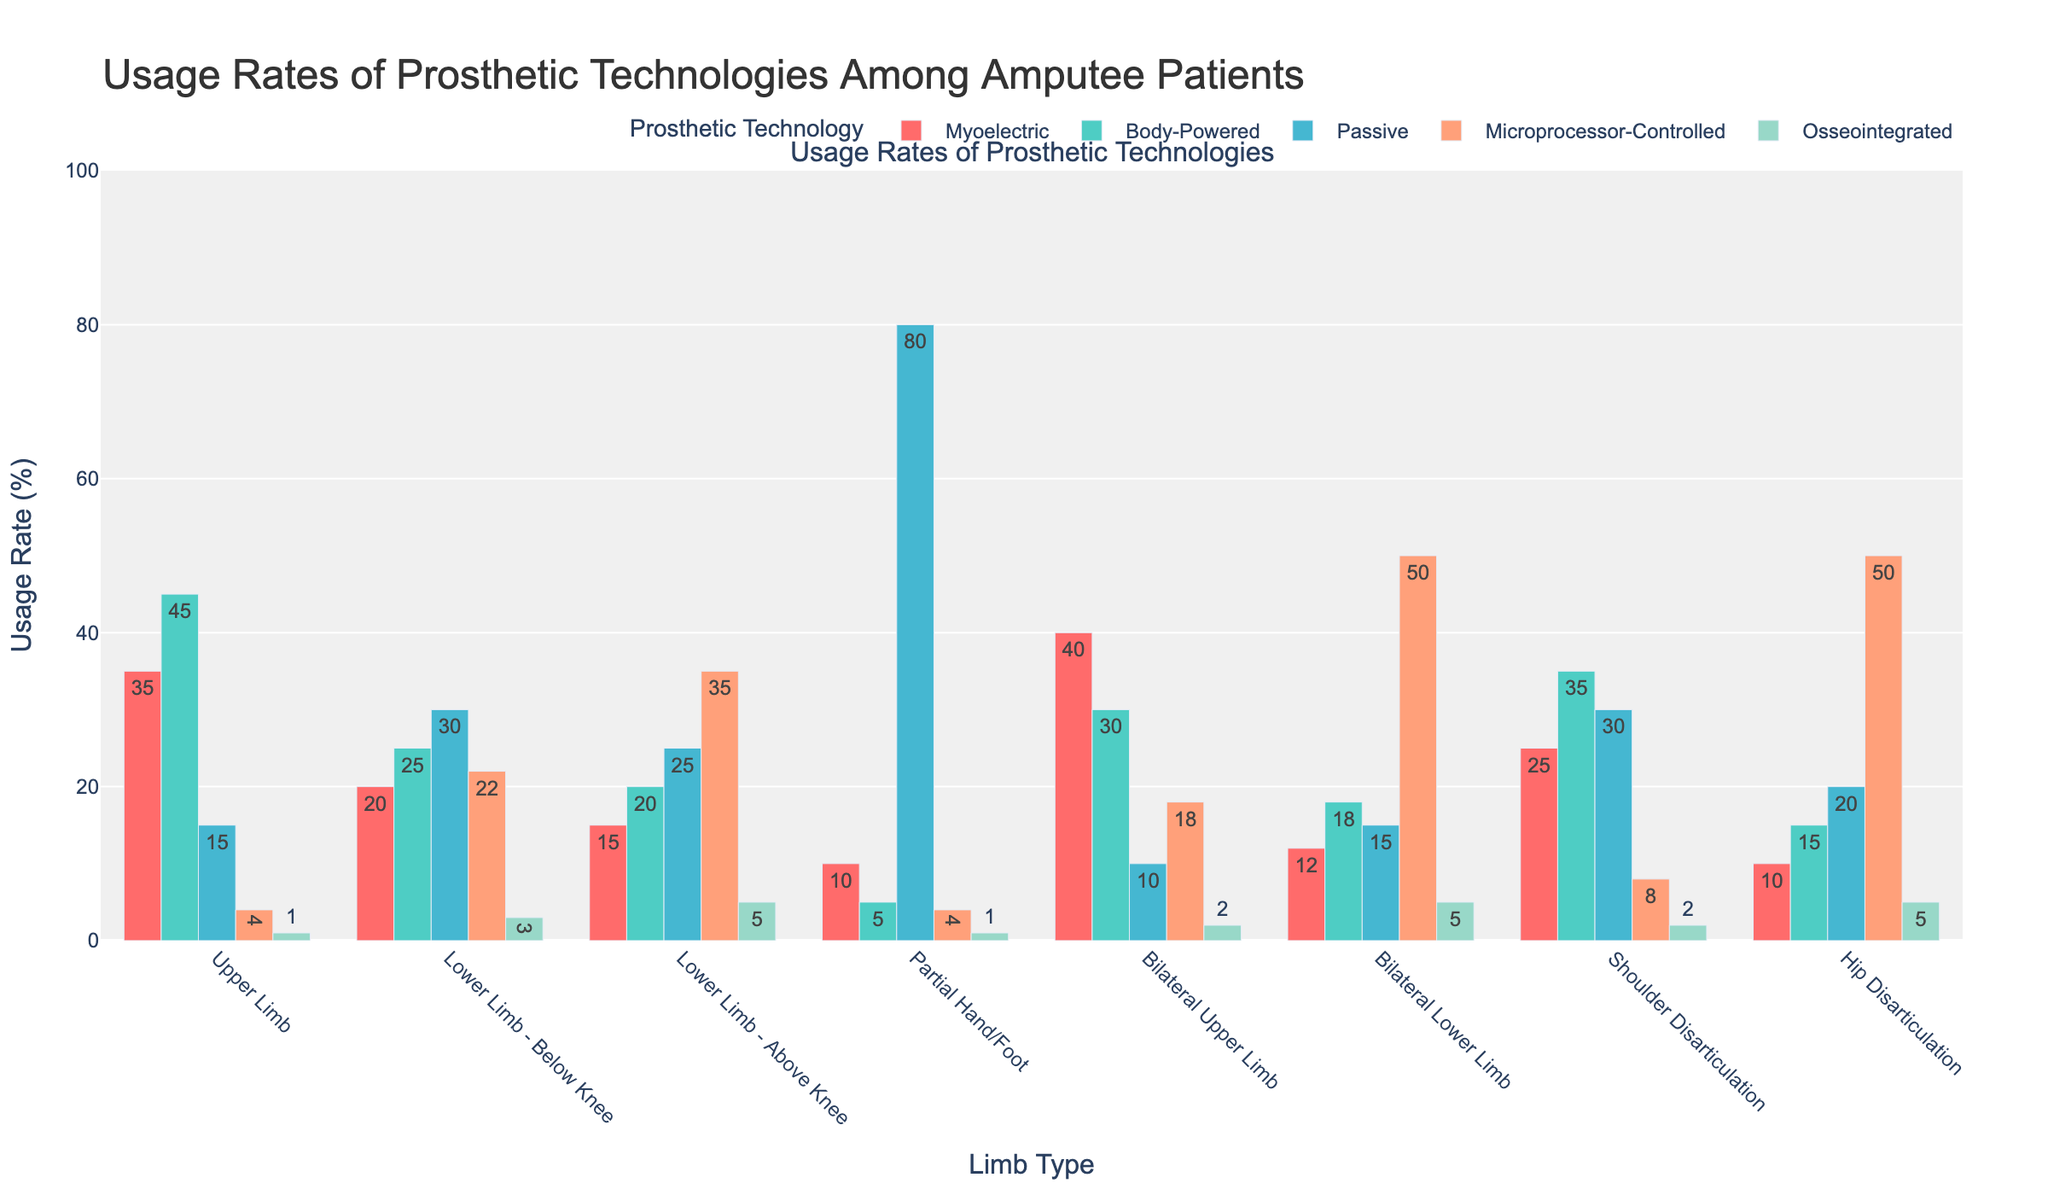Which limb type has the highest usage rate of microprocessor-controlled prosthetics? The limb type with the highest usage rate of microprocessor-controlled prosthetics can be identified by comparing the height of the bars corresponding to microprocessor-controlled prosthetics across different limb types. The tallest bar represents the highest usage rate.
Answer: Bilateral Lower Limb and Hip Disarticulation Which limb type has the least usage rate of osseointegrated prosthetics? To determine the limb type with the least usage rate of osseointegrated prosthetics, look for the shortest bar representing osseointegrated prosthetics across all the limb types.
Answer: Upper Limb and Partial Hand/Foot Compare the usage rates of body-powered prosthetics between upper limb amputees and bilateral upper limb amputees. Which group has a higher usage rate? Compare the height of the body-powered prosthetics bars (likely colored distinctively) for upper limb and bilateral upper limb categories. The taller bar indicates the higher usage rate.
Answer: Upper Limb What is the difference in usage rates between passive prosthetics in upper limb amputees and lower limb - below knee amputees? Identify the bars representing passive prosthetics for both upper limb and lower limb - below knee categories. Subtract the value for upper limb from the value for lower limb - below knee.
Answer: 15 Among the lower limb categories (below knee and above knee), which has a higher usage rate of osseointegrated prosthetics? Compare the height of the osseointegrated prosthetics bars between the two categories. The taller bar indicates the higher usage rate.
Answer: Lower Limb - Above Knee Calculate the average usage rate of microprocessor-controlled prosthetics across all limb types. Sum the usage rates of microprocessor-controlled prosthetics for all categories and divide by the number of categories (8). Calculation: (4+22+35+4+18+50+8+50) / 8 = 191 / 8 = 23.875
Answer: 23.875 Which prosthetic technology has the consistently lowest usage rate across all limb types? Examine the heights of the bars for each prosthetic technology across all limb types and identify the one with the shortest bars on average.
Answer: Osseointegrated How does the usage rate of passive prosthetics in partial hand/foot amputees compare to that in shoulder disarticulation amputees? What is the ratio? Find the bars for passive prosthetics in both partial hand/foot and shoulder disarticulation categories and calculate the ratio of the two values (80/30).
Answer: 8:3 Does the usage rate of body-powered prosthetics exceed that of myoelectric prosthetics in any limb type? If so, which ones? For each limb type, compare the bars for body-powered prosthetics with myoelectric prosthetics. Identify the limb types where the body-powered bar is taller.
Answer: Upper Limb, Lower Limb - Below Knee, Lower Limb - Above Knee, Shoulder Disarticulation Which limb type shows the most balanced usage rates across all prosthetic technologies? Review the bars for each limb type and find the one with the least differences in height among all its bars, indicating more balanced usage rates across the technologies.
Answer: Bilateral Upper Limb 